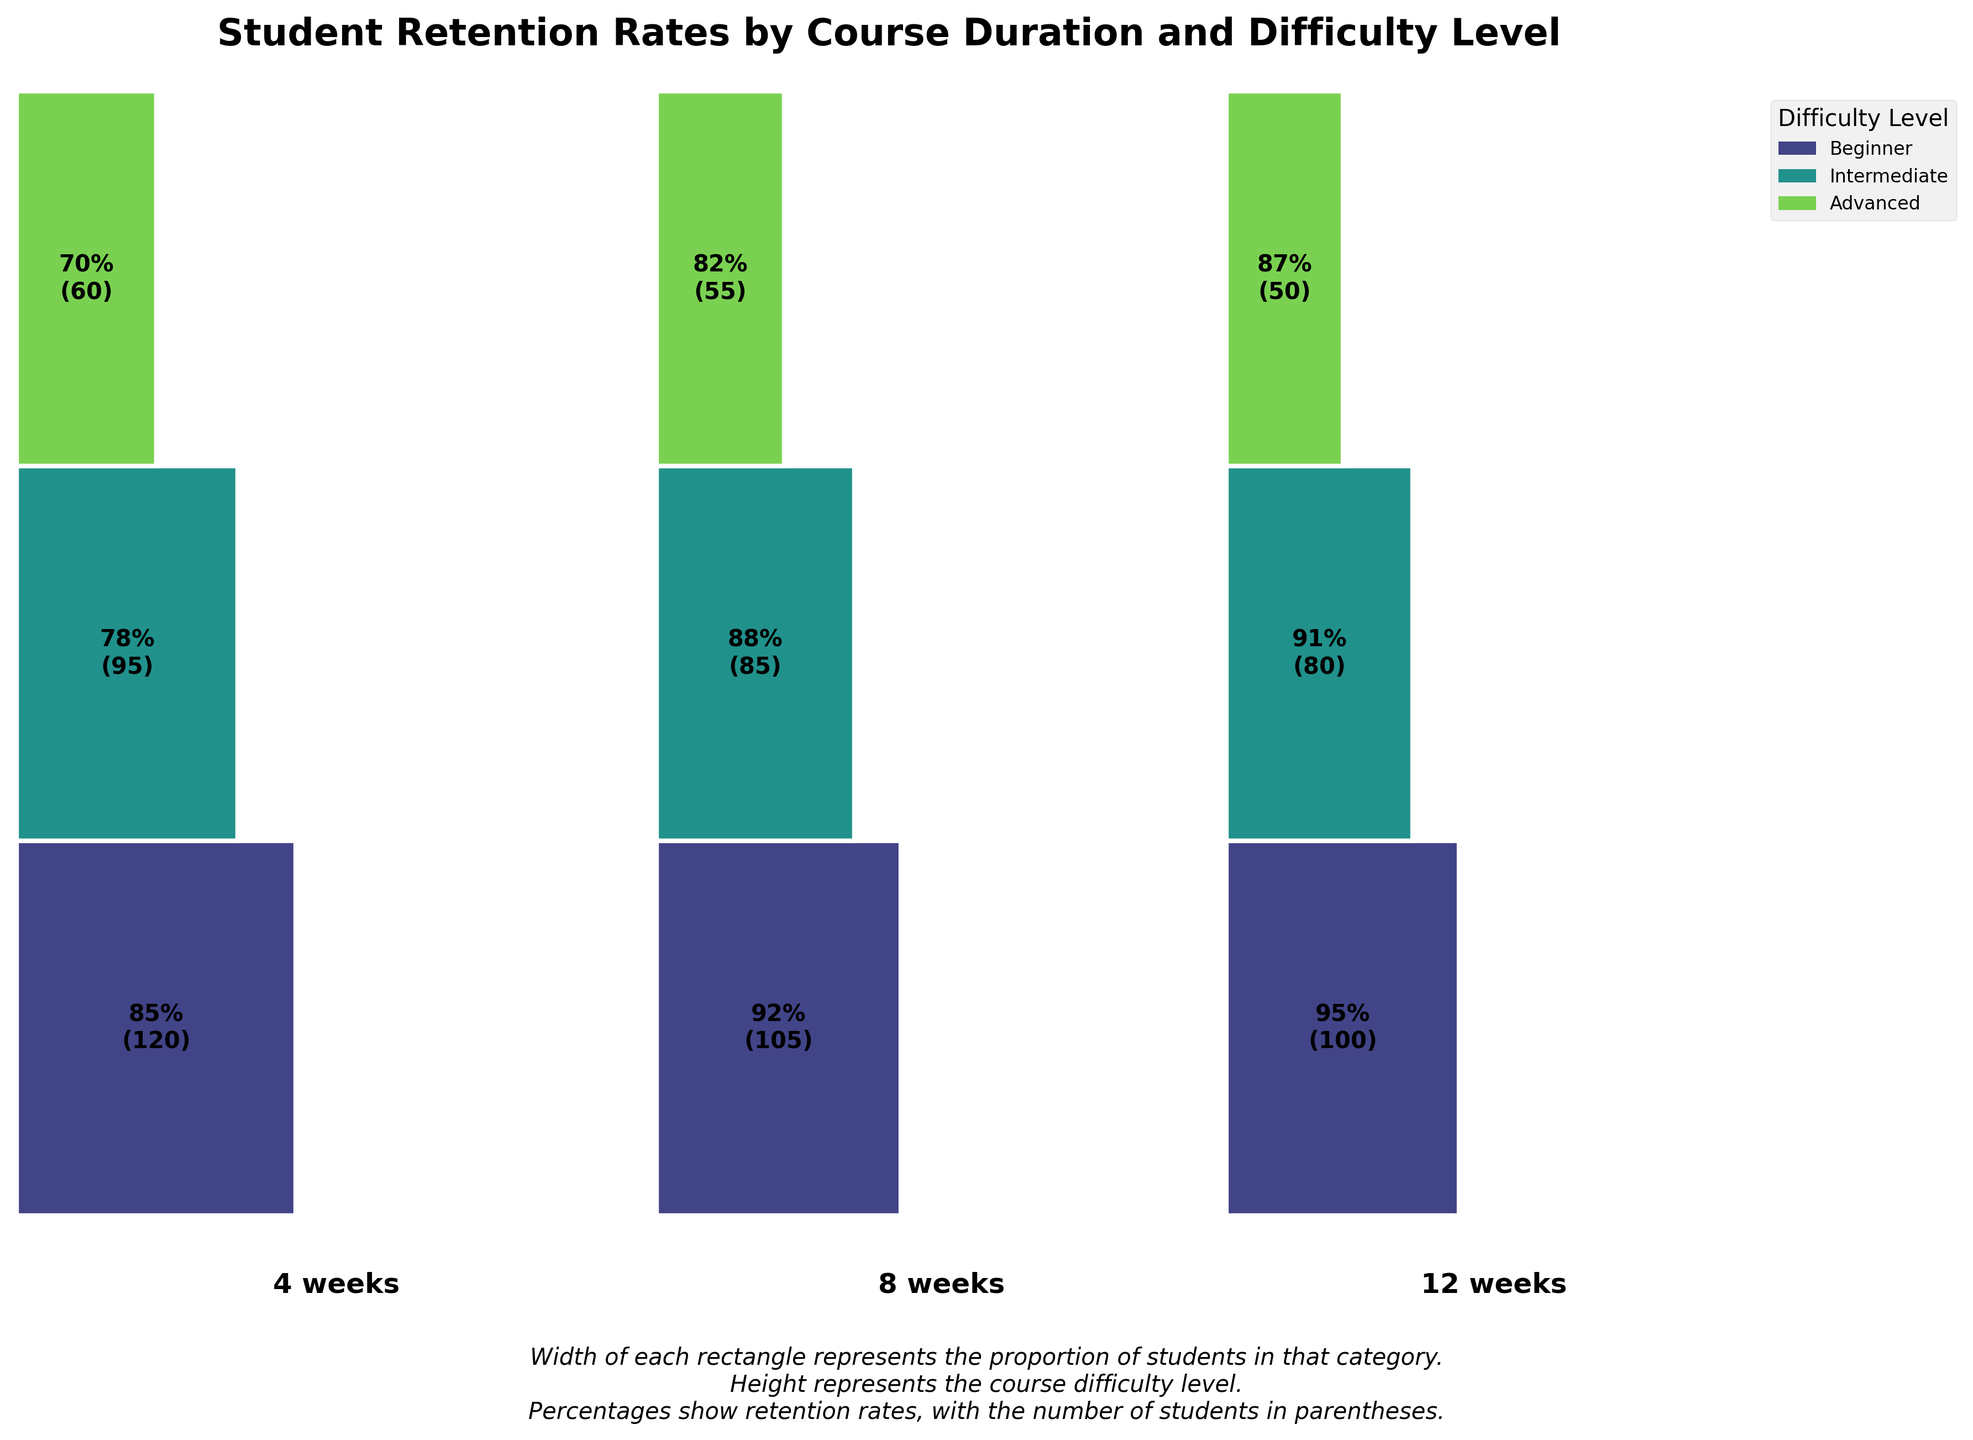Which course duration has the highest retention rate for beginner level? Look at the retention rates for the beginner level across all course durations. The highest retention rate for beginners is 95% for the 12-week course.
Answer: 12 weeks How many students are in the 8-week intermediate course? Look at the number of students shown in parentheses for the 8-week intermediate course. The number of students is 85.
Answer: 85 What's the total number of students in the advanced difficulty level across all course durations? Sum the number of students in the advanced difficulty level for 4 weeks, 8 weeks, and 12 weeks: 60 + 55 + 50 = 165.
Answer: 165 Which difficulty level has the highest retention rate for the 4-week course duration? Look at the retention rates for the 4-week duration across all difficulty levels. The highest retention rate is 85% for the beginner level.
Answer: Beginner Which course duration has the most students overall? Sum the number of students for all difficulty levels within each course duration. For 4 weeks: 120 + 95 + 60 = 275. For 8 weeks: 105 + 85 + 55 = 245. For 12 weeks: 100 + 80 + 50 = 230. The 4-week duration has the most students.
Answer: 4 weeks Between the 8-week and 12-week courses, which intermediate course has the higher retention rate? Compare the retention rates for the intermediate difficulty level between the 8-week and 12-week courses. The 12-week course has a retention rate of 91%, while the 8-week course has 88%.
Answer: 12 weeks What is the retention rate for the 12-week advanced course? Look at the retention rates for the advanced level in the 12-week duration. The retention rate is 87%.
Answer: 87% How does the retention rate of the 4-week advanced course compare to the 8-week advanced course? Compare the retention rates of the advanced difficulty level between the 4-week and 8-week courses. The 4-week course has a retention rate of 70%, while the 8-week course has 82%.
Answer: 8 weeks is higher Which difficulty level has the most students in total? Sum the number of students across all course durations within each difficulty level. Beginner: 120 + 105 + 100 = 325. Intermediate: 95 + 85 + 80 = 260. Advanced: 60 + 55 + 50 = 165. The beginner level has the most students.
Answer: Beginner 